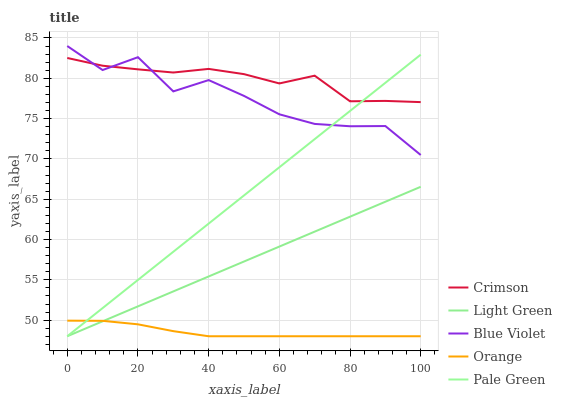Does Orange have the minimum area under the curve?
Answer yes or no. Yes. Does Crimson have the maximum area under the curve?
Answer yes or no. Yes. Does Pale Green have the minimum area under the curve?
Answer yes or no. No. Does Pale Green have the maximum area under the curve?
Answer yes or no. No. Is Light Green the smoothest?
Answer yes or no. Yes. Is Blue Violet the roughest?
Answer yes or no. Yes. Is Orange the smoothest?
Answer yes or no. No. Is Orange the roughest?
Answer yes or no. No. Does Orange have the lowest value?
Answer yes or no. Yes. Does Blue Violet have the lowest value?
Answer yes or no. No. Does Blue Violet have the highest value?
Answer yes or no. Yes. Does Pale Green have the highest value?
Answer yes or no. No. Is Light Green less than Crimson?
Answer yes or no. Yes. Is Crimson greater than Orange?
Answer yes or no. Yes. Does Blue Violet intersect Crimson?
Answer yes or no. Yes. Is Blue Violet less than Crimson?
Answer yes or no. No. Is Blue Violet greater than Crimson?
Answer yes or no. No. Does Light Green intersect Crimson?
Answer yes or no. No. 